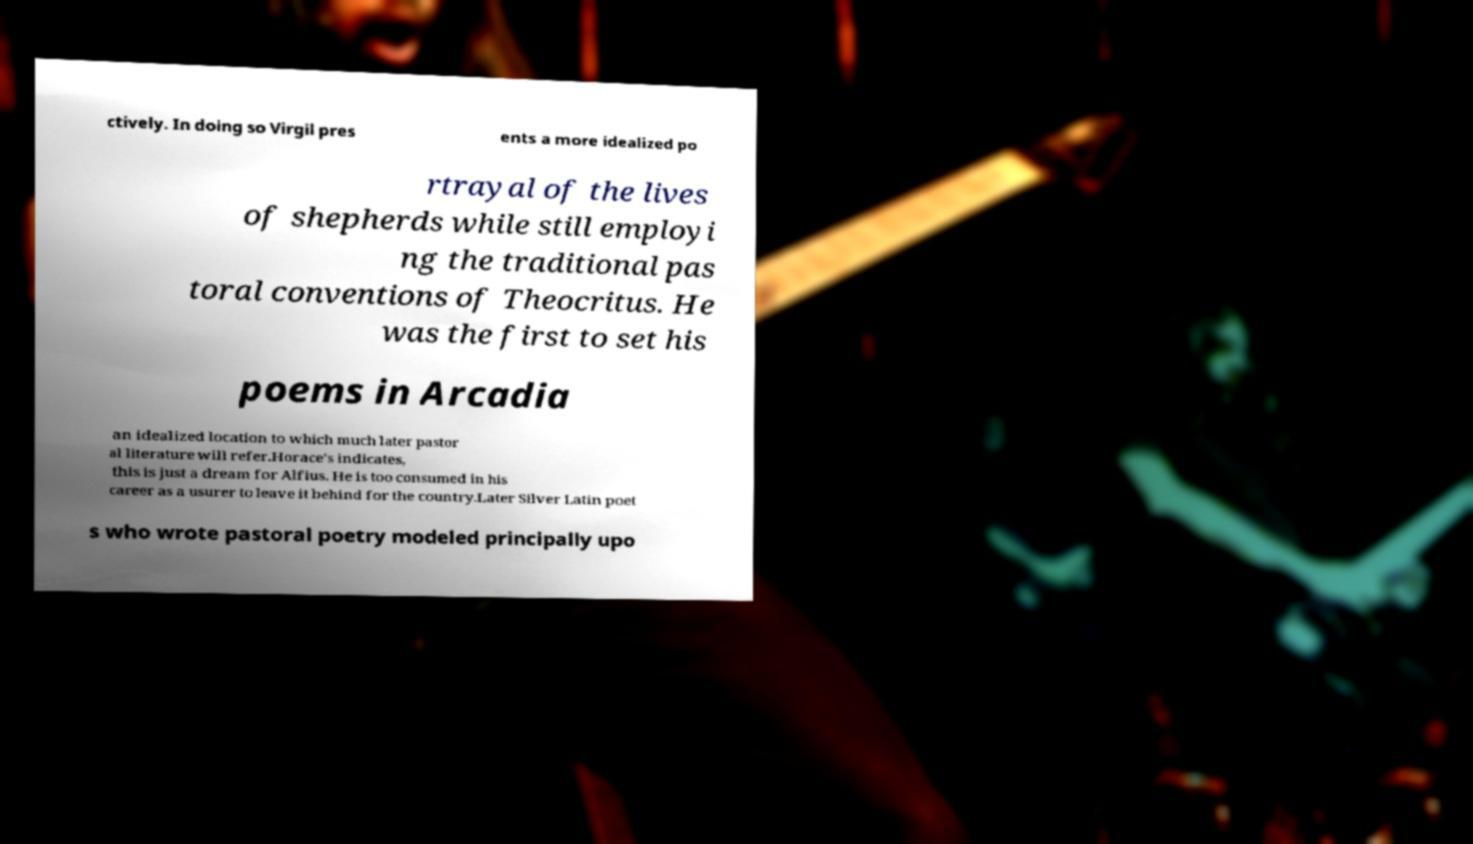For documentation purposes, I need the text within this image transcribed. Could you provide that? ctively. In doing so Virgil pres ents a more idealized po rtrayal of the lives of shepherds while still employi ng the traditional pas toral conventions of Theocritus. He was the first to set his poems in Arcadia an idealized location to which much later pastor al literature will refer.Horace's indicates, this is just a dream for Alfius. He is too consumed in his career as a usurer to leave it behind for the country.Later Silver Latin poet s who wrote pastoral poetry modeled principally upo 